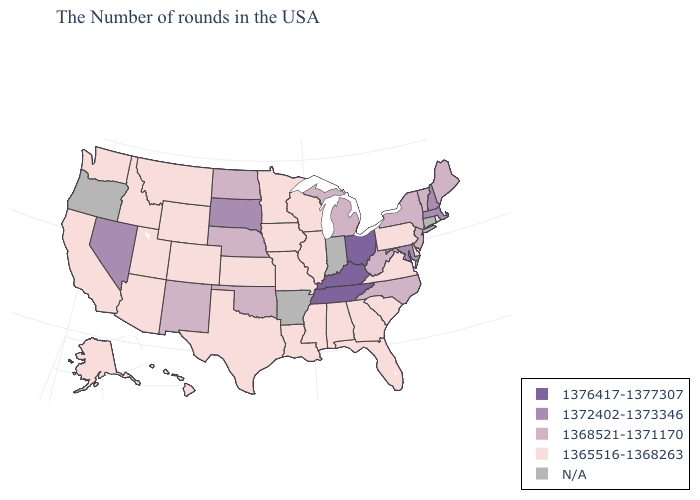What is the lowest value in the USA?
Quick response, please. 1365516-1368263. What is the value of Hawaii?
Answer briefly. 1365516-1368263. Name the states that have a value in the range N/A?
Short answer required. Connecticut, Indiana, Arkansas, Oregon. Which states have the highest value in the USA?
Give a very brief answer. Ohio, Kentucky, Tennessee. Name the states that have a value in the range 1376417-1377307?
Quick response, please. Ohio, Kentucky, Tennessee. What is the highest value in the Northeast ?
Answer briefly. 1372402-1373346. What is the value of Illinois?
Answer briefly. 1365516-1368263. What is the lowest value in the USA?
Write a very short answer. 1365516-1368263. Among the states that border West Virginia , does Maryland have the lowest value?
Short answer required. No. What is the highest value in the USA?
Write a very short answer. 1376417-1377307. Does Kentucky have the highest value in the South?
Keep it brief. Yes. Name the states that have a value in the range N/A?
Write a very short answer. Connecticut, Indiana, Arkansas, Oregon. What is the value of Michigan?
Answer briefly. 1368521-1371170. What is the lowest value in the Northeast?
Quick response, please. 1365516-1368263. 